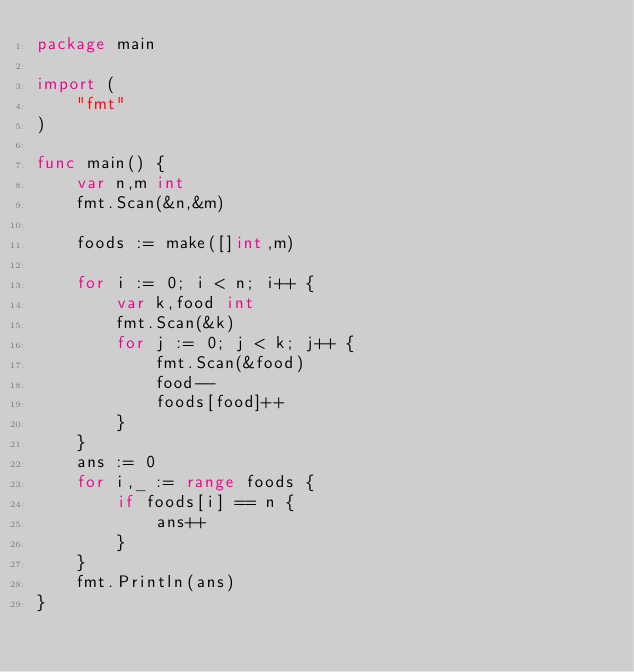<code> <loc_0><loc_0><loc_500><loc_500><_Go_>package main

import (
	"fmt"
)

func main() {
	var n,m int
	fmt.Scan(&n,&m)
	
	foods := make([]int,m)
	
	for i := 0; i < n; i++ {
		var k,food int
		fmt.Scan(&k)
		for j := 0; j < k; j++ {
			fmt.Scan(&food)
			food--
			foods[food]++
		}
	}
	ans := 0
	for i,_ := range foods {
		if foods[i] == n {
			ans++
		}
	}
	fmt.Println(ans)
}</code> 